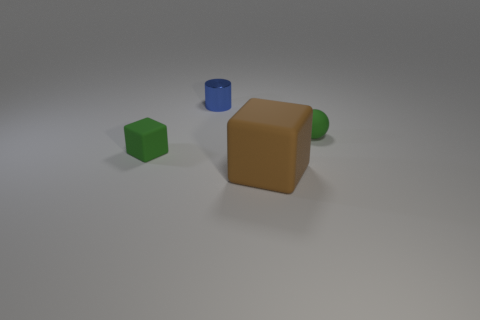Subtract all red spheres. Subtract all green cubes. How many spheres are left? 1 Add 4 big purple matte objects. How many objects exist? 8 Subtract all cylinders. How many objects are left? 3 Subtract 0 cyan balls. How many objects are left? 4 Subtract all rubber things. Subtract all large green rubber blocks. How many objects are left? 1 Add 2 small blue objects. How many small blue objects are left? 3 Add 1 tiny metallic cylinders. How many tiny metallic cylinders exist? 2 